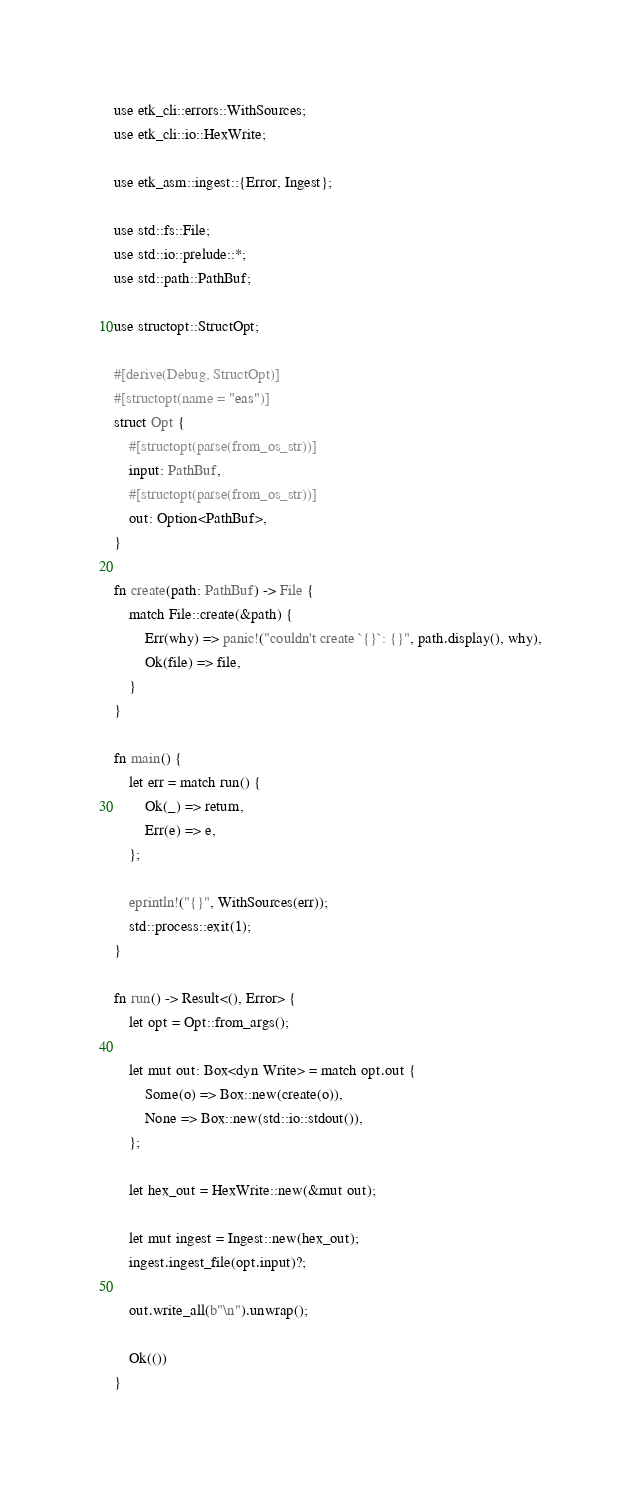<code> <loc_0><loc_0><loc_500><loc_500><_Rust_>use etk_cli::errors::WithSources;
use etk_cli::io::HexWrite;

use etk_asm::ingest::{Error, Ingest};

use std::fs::File;
use std::io::prelude::*;
use std::path::PathBuf;

use structopt::StructOpt;

#[derive(Debug, StructOpt)]
#[structopt(name = "eas")]
struct Opt {
    #[structopt(parse(from_os_str))]
    input: PathBuf,
    #[structopt(parse(from_os_str))]
    out: Option<PathBuf>,
}

fn create(path: PathBuf) -> File {
    match File::create(&path) {
        Err(why) => panic!("couldn't create `{}`: {}", path.display(), why),
        Ok(file) => file,
    }
}

fn main() {
    let err = match run() {
        Ok(_) => return,
        Err(e) => e,
    };

    eprintln!("{}", WithSources(err));
    std::process::exit(1);
}

fn run() -> Result<(), Error> {
    let opt = Opt::from_args();

    let mut out: Box<dyn Write> = match opt.out {
        Some(o) => Box::new(create(o)),
        None => Box::new(std::io::stdout()),
    };

    let hex_out = HexWrite::new(&mut out);

    let mut ingest = Ingest::new(hex_out);
    ingest.ingest_file(opt.input)?;

    out.write_all(b"\n").unwrap();

    Ok(())
}
</code> 